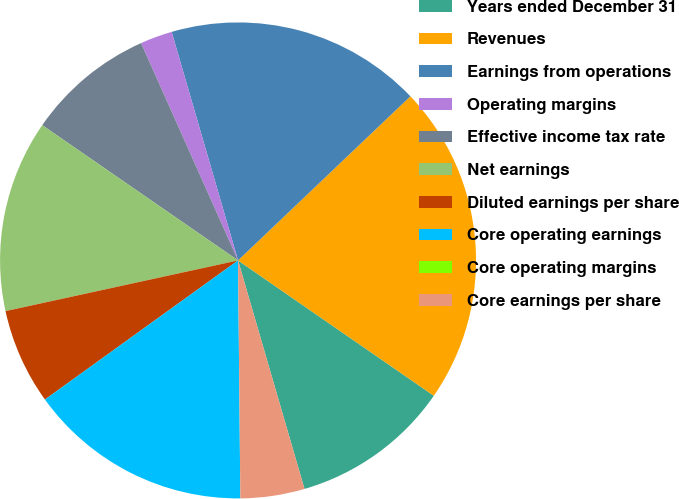Convert chart. <chart><loc_0><loc_0><loc_500><loc_500><pie_chart><fcel>Years ended December 31<fcel>Revenues<fcel>Earnings from operations<fcel>Operating margins<fcel>Effective income tax rate<fcel>Net earnings<fcel>Diluted earnings per share<fcel>Core operating earnings<fcel>Core operating margins<fcel>Core earnings per share<nl><fcel>10.87%<fcel>21.74%<fcel>17.39%<fcel>2.18%<fcel>8.7%<fcel>13.04%<fcel>6.52%<fcel>15.22%<fcel>0.0%<fcel>4.35%<nl></chart> 